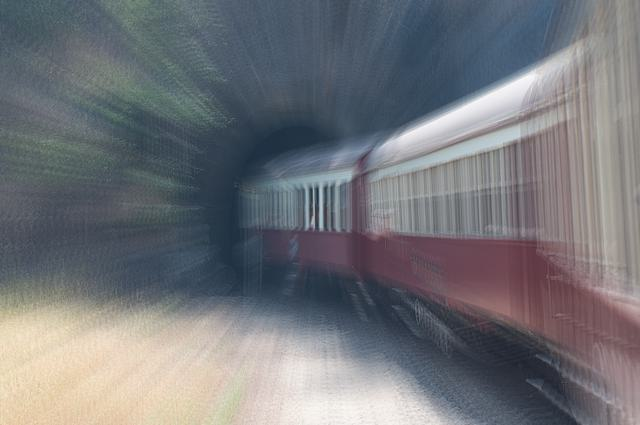What does the overall clarity indicate about the image quality? While the blurring effect in the image suggests a photographic technique to convey movement, particularly with the train appearing to speed into a tunnel, it does not inherently imply low image quality. The clarity of the image is not perfect, nor high in a traditional sense, but rather artistically stylized to emphasize motion and speed. The photo's aesthetic value should be assessed within the context of its intention to depict dynamism. 